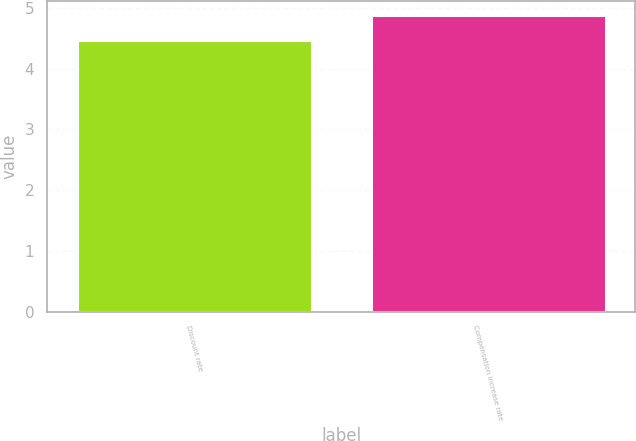Convert chart to OTSL. <chart><loc_0><loc_0><loc_500><loc_500><bar_chart><fcel>Discount rate<fcel>Compensation increase rate<nl><fcel>4.47<fcel>4.88<nl></chart> 